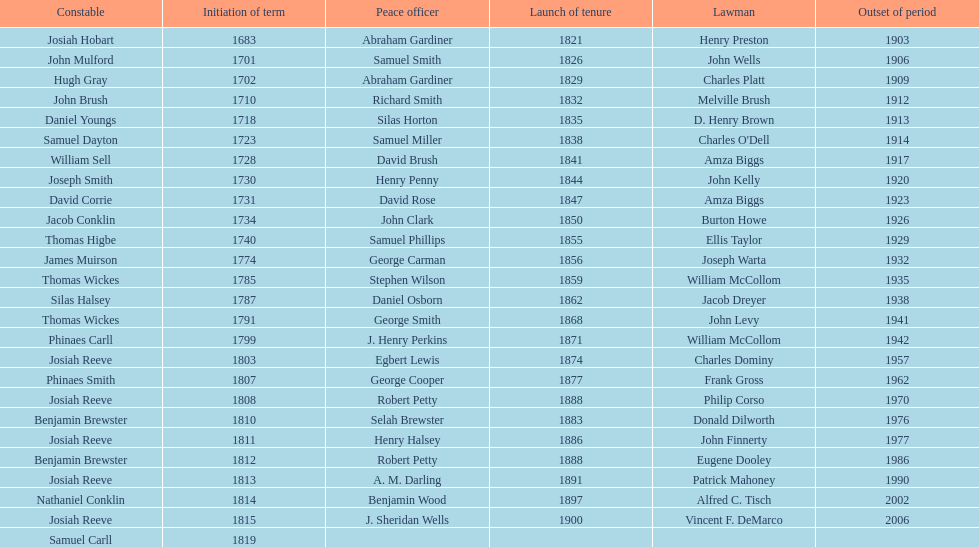How sheriffs has suffolk county had in total? 76. Give me the full table as a dictionary. {'header': ['Constable', 'Initiation of term', 'Peace officer', 'Launch of tenure', 'Lawman', 'Outset of period'], 'rows': [['Josiah Hobart', '1683', 'Abraham Gardiner', '1821', 'Henry Preston', '1903'], ['John Mulford', '1701', 'Samuel Smith', '1826', 'John Wells', '1906'], ['Hugh Gray', '1702', 'Abraham Gardiner', '1829', 'Charles Platt', '1909'], ['John Brush', '1710', 'Richard Smith', '1832', 'Melville Brush', '1912'], ['Daniel Youngs', '1718', 'Silas Horton', '1835', 'D. Henry Brown', '1913'], ['Samuel Dayton', '1723', 'Samuel Miller', '1838', "Charles O'Dell", '1914'], ['William Sell', '1728', 'David Brush', '1841', 'Amza Biggs', '1917'], ['Joseph Smith', '1730', 'Henry Penny', '1844', 'John Kelly', '1920'], ['David Corrie', '1731', 'David Rose', '1847', 'Amza Biggs', '1923'], ['Jacob Conklin', '1734', 'John Clark', '1850', 'Burton Howe', '1926'], ['Thomas Higbe', '1740', 'Samuel Phillips', '1855', 'Ellis Taylor', '1929'], ['James Muirson', '1774', 'George Carman', '1856', 'Joseph Warta', '1932'], ['Thomas Wickes', '1785', 'Stephen Wilson', '1859', 'William McCollom', '1935'], ['Silas Halsey', '1787', 'Daniel Osborn', '1862', 'Jacob Dreyer', '1938'], ['Thomas Wickes', '1791', 'George Smith', '1868', 'John Levy', '1941'], ['Phinaes Carll', '1799', 'J. Henry Perkins', '1871', 'William McCollom', '1942'], ['Josiah Reeve', '1803', 'Egbert Lewis', '1874', 'Charles Dominy', '1957'], ['Phinaes Smith', '1807', 'George Cooper', '1877', 'Frank Gross', '1962'], ['Josiah Reeve', '1808', 'Robert Petty', '1888', 'Philip Corso', '1970'], ['Benjamin Brewster', '1810', 'Selah Brewster', '1883', 'Donald Dilworth', '1976'], ['Josiah Reeve', '1811', 'Henry Halsey', '1886', 'John Finnerty', '1977'], ['Benjamin Brewster', '1812', 'Robert Petty', '1888', 'Eugene Dooley', '1986'], ['Josiah Reeve', '1813', 'A. M. Darling', '1891', 'Patrick Mahoney', '1990'], ['Nathaniel Conklin', '1814', 'Benjamin Wood', '1897', 'Alfred C. Tisch', '2002'], ['Josiah Reeve', '1815', 'J. Sheridan Wells', '1900', 'Vincent F. DeMarco', '2006'], ['Samuel Carll', '1819', '', '', '', '']]} 